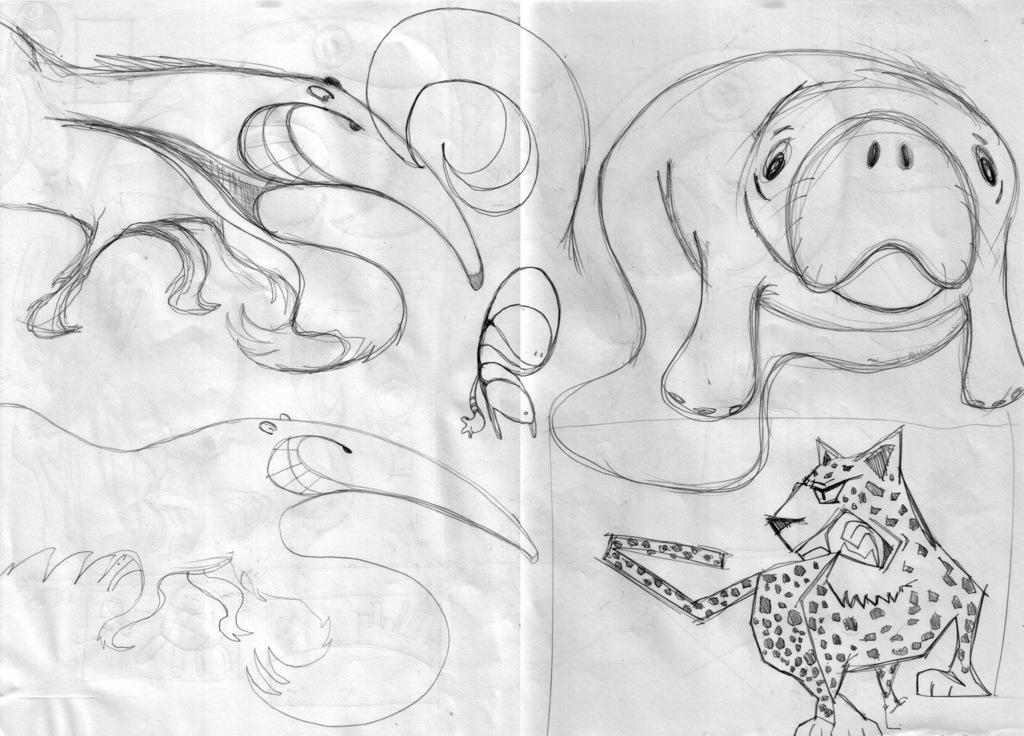Can you describe this image briefly? In the center of the image we can see one paper. On the paper, we can see some drawings of animals. 